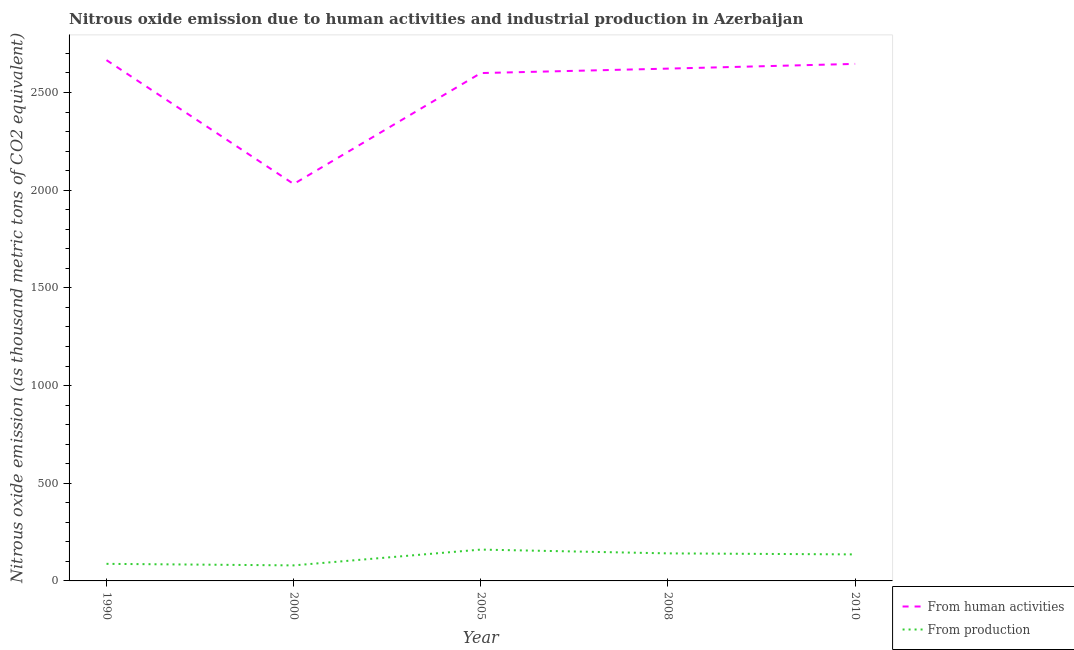Does the line corresponding to amount of emissions generated from industries intersect with the line corresponding to amount of emissions from human activities?
Offer a very short reply. No. What is the amount of emissions from human activities in 2000?
Ensure brevity in your answer.  2031.7. Across all years, what is the maximum amount of emissions from human activities?
Keep it short and to the point. 2665.8. Across all years, what is the minimum amount of emissions from human activities?
Your answer should be very brief. 2031.7. In which year was the amount of emissions from human activities maximum?
Ensure brevity in your answer.  1990. What is the total amount of emissions generated from industries in the graph?
Your response must be concise. 604. What is the difference between the amount of emissions generated from industries in 2000 and that in 2008?
Ensure brevity in your answer.  -61.5. What is the difference between the amount of emissions generated from industries in 2008 and the amount of emissions from human activities in 2005?
Keep it short and to the point. -2458.6. What is the average amount of emissions generated from industries per year?
Your response must be concise. 120.8. In the year 2005, what is the difference between the amount of emissions generated from industries and amount of emissions from human activities?
Ensure brevity in your answer.  -2439.2. What is the ratio of the amount of emissions generated from industries in 1990 to that in 2008?
Offer a terse response. 0.62. Is the difference between the amount of emissions from human activities in 2000 and 2005 greater than the difference between the amount of emissions generated from industries in 2000 and 2005?
Offer a very short reply. No. What is the difference between the highest and the second highest amount of emissions generated from industries?
Your answer should be very brief. 19.4. What is the difference between the highest and the lowest amount of emissions from human activities?
Keep it short and to the point. 634.1. In how many years, is the amount of emissions from human activities greater than the average amount of emissions from human activities taken over all years?
Keep it short and to the point. 4. Is the sum of the amount of emissions generated from industries in 1990 and 2008 greater than the maximum amount of emissions from human activities across all years?
Make the answer very short. No. Does the amount of emissions from human activities monotonically increase over the years?
Offer a very short reply. No. Is the amount of emissions generated from industries strictly greater than the amount of emissions from human activities over the years?
Your response must be concise. No. Is the amount of emissions from human activities strictly less than the amount of emissions generated from industries over the years?
Make the answer very short. No. How many years are there in the graph?
Give a very brief answer. 5. What is the difference between two consecutive major ticks on the Y-axis?
Ensure brevity in your answer.  500. Are the values on the major ticks of Y-axis written in scientific E-notation?
Your answer should be compact. No. How many legend labels are there?
Your response must be concise. 2. How are the legend labels stacked?
Ensure brevity in your answer.  Vertical. What is the title of the graph?
Provide a short and direct response. Nitrous oxide emission due to human activities and industrial production in Azerbaijan. What is the label or title of the Y-axis?
Provide a short and direct response. Nitrous oxide emission (as thousand metric tons of CO2 equivalent). What is the Nitrous oxide emission (as thousand metric tons of CO2 equivalent) in From human activities in 1990?
Your answer should be compact. 2665.8. What is the Nitrous oxide emission (as thousand metric tons of CO2 equivalent) of From production in 1990?
Ensure brevity in your answer.  87.4. What is the Nitrous oxide emission (as thousand metric tons of CO2 equivalent) in From human activities in 2000?
Provide a succinct answer. 2031.7. What is the Nitrous oxide emission (as thousand metric tons of CO2 equivalent) of From production in 2000?
Provide a short and direct response. 79.5. What is the Nitrous oxide emission (as thousand metric tons of CO2 equivalent) of From human activities in 2005?
Ensure brevity in your answer.  2599.6. What is the Nitrous oxide emission (as thousand metric tons of CO2 equivalent) in From production in 2005?
Your response must be concise. 160.4. What is the Nitrous oxide emission (as thousand metric tons of CO2 equivalent) in From human activities in 2008?
Keep it short and to the point. 2622.4. What is the Nitrous oxide emission (as thousand metric tons of CO2 equivalent) in From production in 2008?
Your response must be concise. 141. What is the Nitrous oxide emission (as thousand metric tons of CO2 equivalent) of From human activities in 2010?
Provide a short and direct response. 2646.6. What is the Nitrous oxide emission (as thousand metric tons of CO2 equivalent) of From production in 2010?
Give a very brief answer. 135.7. Across all years, what is the maximum Nitrous oxide emission (as thousand metric tons of CO2 equivalent) in From human activities?
Give a very brief answer. 2665.8. Across all years, what is the maximum Nitrous oxide emission (as thousand metric tons of CO2 equivalent) in From production?
Offer a terse response. 160.4. Across all years, what is the minimum Nitrous oxide emission (as thousand metric tons of CO2 equivalent) in From human activities?
Your answer should be compact. 2031.7. Across all years, what is the minimum Nitrous oxide emission (as thousand metric tons of CO2 equivalent) of From production?
Your response must be concise. 79.5. What is the total Nitrous oxide emission (as thousand metric tons of CO2 equivalent) in From human activities in the graph?
Your answer should be compact. 1.26e+04. What is the total Nitrous oxide emission (as thousand metric tons of CO2 equivalent) in From production in the graph?
Your response must be concise. 604. What is the difference between the Nitrous oxide emission (as thousand metric tons of CO2 equivalent) in From human activities in 1990 and that in 2000?
Keep it short and to the point. 634.1. What is the difference between the Nitrous oxide emission (as thousand metric tons of CO2 equivalent) in From production in 1990 and that in 2000?
Make the answer very short. 7.9. What is the difference between the Nitrous oxide emission (as thousand metric tons of CO2 equivalent) of From human activities in 1990 and that in 2005?
Ensure brevity in your answer.  66.2. What is the difference between the Nitrous oxide emission (as thousand metric tons of CO2 equivalent) in From production in 1990 and that in 2005?
Make the answer very short. -73. What is the difference between the Nitrous oxide emission (as thousand metric tons of CO2 equivalent) of From human activities in 1990 and that in 2008?
Offer a terse response. 43.4. What is the difference between the Nitrous oxide emission (as thousand metric tons of CO2 equivalent) in From production in 1990 and that in 2008?
Provide a short and direct response. -53.6. What is the difference between the Nitrous oxide emission (as thousand metric tons of CO2 equivalent) in From human activities in 1990 and that in 2010?
Provide a short and direct response. 19.2. What is the difference between the Nitrous oxide emission (as thousand metric tons of CO2 equivalent) of From production in 1990 and that in 2010?
Offer a very short reply. -48.3. What is the difference between the Nitrous oxide emission (as thousand metric tons of CO2 equivalent) in From human activities in 2000 and that in 2005?
Offer a terse response. -567.9. What is the difference between the Nitrous oxide emission (as thousand metric tons of CO2 equivalent) in From production in 2000 and that in 2005?
Provide a short and direct response. -80.9. What is the difference between the Nitrous oxide emission (as thousand metric tons of CO2 equivalent) in From human activities in 2000 and that in 2008?
Your answer should be very brief. -590.7. What is the difference between the Nitrous oxide emission (as thousand metric tons of CO2 equivalent) of From production in 2000 and that in 2008?
Provide a short and direct response. -61.5. What is the difference between the Nitrous oxide emission (as thousand metric tons of CO2 equivalent) in From human activities in 2000 and that in 2010?
Your response must be concise. -614.9. What is the difference between the Nitrous oxide emission (as thousand metric tons of CO2 equivalent) of From production in 2000 and that in 2010?
Your response must be concise. -56.2. What is the difference between the Nitrous oxide emission (as thousand metric tons of CO2 equivalent) in From human activities in 2005 and that in 2008?
Ensure brevity in your answer.  -22.8. What is the difference between the Nitrous oxide emission (as thousand metric tons of CO2 equivalent) of From human activities in 2005 and that in 2010?
Provide a succinct answer. -47. What is the difference between the Nitrous oxide emission (as thousand metric tons of CO2 equivalent) of From production in 2005 and that in 2010?
Offer a very short reply. 24.7. What is the difference between the Nitrous oxide emission (as thousand metric tons of CO2 equivalent) of From human activities in 2008 and that in 2010?
Make the answer very short. -24.2. What is the difference between the Nitrous oxide emission (as thousand metric tons of CO2 equivalent) of From production in 2008 and that in 2010?
Make the answer very short. 5.3. What is the difference between the Nitrous oxide emission (as thousand metric tons of CO2 equivalent) in From human activities in 1990 and the Nitrous oxide emission (as thousand metric tons of CO2 equivalent) in From production in 2000?
Your answer should be very brief. 2586.3. What is the difference between the Nitrous oxide emission (as thousand metric tons of CO2 equivalent) in From human activities in 1990 and the Nitrous oxide emission (as thousand metric tons of CO2 equivalent) in From production in 2005?
Give a very brief answer. 2505.4. What is the difference between the Nitrous oxide emission (as thousand metric tons of CO2 equivalent) of From human activities in 1990 and the Nitrous oxide emission (as thousand metric tons of CO2 equivalent) of From production in 2008?
Make the answer very short. 2524.8. What is the difference between the Nitrous oxide emission (as thousand metric tons of CO2 equivalent) in From human activities in 1990 and the Nitrous oxide emission (as thousand metric tons of CO2 equivalent) in From production in 2010?
Offer a very short reply. 2530.1. What is the difference between the Nitrous oxide emission (as thousand metric tons of CO2 equivalent) of From human activities in 2000 and the Nitrous oxide emission (as thousand metric tons of CO2 equivalent) of From production in 2005?
Provide a succinct answer. 1871.3. What is the difference between the Nitrous oxide emission (as thousand metric tons of CO2 equivalent) of From human activities in 2000 and the Nitrous oxide emission (as thousand metric tons of CO2 equivalent) of From production in 2008?
Your response must be concise. 1890.7. What is the difference between the Nitrous oxide emission (as thousand metric tons of CO2 equivalent) of From human activities in 2000 and the Nitrous oxide emission (as thousand metric tons of CO2 equivalent) of From production in 2010?
Offer a very short reply. 1896. What is the difference between the Nitrous oxide emission (as thousand metric tons of CO2 equivalent) of From human activities in 2005 and the Nitrous oxide emission (as thousand metric tons of CO2 equivalent) of From production in 2008?
Provide a short and direct response. 2458.6. What is the difference between the Nitrous oxide emission (as thousand metric tons of CO2 equivalent) of From human activities in 2005 and the Nitrous oxide emission (as thousand metric tons of CO2 equivalent) of From production in 2010?
Keep it short and to the point. 2463.9. What is the difference between the Nitrous oxide emission (as thousand metric tons of CO2 equivalent) in From human activities in 2008 and the Nitrous oxide emission (as thousand metric tons of CO2 equivalent) in From production in 2010?
Provide a succinct answer. 2486.7. What is the average Nitrous oxide emission (as thousand metric tons of CO2 equivalent) in From human activities per year?
Provide a succinct answer. 2513.22. What is the average Nitrous oxide emission (as thousand metric tons of CO2 equivalent) of From production per year?
Provide a succinct answer. 120.8. In the year 1990, what is the difference between the Nitrous oxide emission (as thousand metric tons of CO2 equivalent) in From human activities and Nitrous oxide emission (as thousand metric tons of CO2 equivalent) in From production?
Ensure brevity in your answer.  2578.4. In the year 2000, what is the difference between the Nitrous oxide emission (as thousand metric tons of CO2 equivalent) in From human activities and Nitrous oxide emission (as thousand metric tons of CO2 equivalent) in From production?
Provide a succinct answer. 1952.2. In the year 2005, what is the difference between the Nitrous oxide emission (as thousand metric tons of CO2 equivalent) in From human activities and Nitrous oxide emission (as thousand metric tons of CO2 equivalent) in From production?
Provide a short and direct response. 2439.2. In the year 2008, what is the difference between the Nitrous oxide emission (as thousand metric tons of CO2 equivalent) of From human activities and Nitrous oxide emission (as thousand metric tons of CO2 equivalent) of From production?
Provide a succinct answer. 2481.4. In the year 2010, what is the difference between the Nitrous oxide emission (as thousand metric tons of CO2 equivalent) in From human activities and Nitrous oxide emission (as thousand metric tons of CO2 equivalent) in From production?
Your answer should be very brief. 2510.9. What is the ratio of the Nitrous oxide emission (as thousand metric tons of CO2 equivalent) of From human activities in 1990 to that in 2000?
Keep it short and to the point. 1.31. What is the ratio of the Nitrous oxide emission (as thousand metric tons of CO2 equivalent) of From production in 1990 to that in 2000?
Offer a terse response. 1.1. What is the ratio of the Nitrous oxide emission (as thousand metric tons of CO2 equivalent) in From human activities in 1990 to that in 2005?
Keep it short and to the point. 1.03. What is the ratio of the Nitrous oxide emission (as thousand metric tons of CO2 equivalent) in From production in 1990 to that in 2005?
Make the answer very short. 0.54. What is the ratio of the Nitrous oxide emission (as thousand metric tons of CO2 equivalent) in From human activities in 1990 to that in 2008?
Offer a very short reply. 1.02. What is the ratio of the Nitrous oxide emission (as thousand metric tons of CO2 equivalent) in From production in 1990 to that in 2008?
Offer a terse response. 0.62. What is the ratio of the Nitrous oxide emission (as thousand metric tons of CO2 equivalent) of From human activities in 1990 to that in 2010?
Your answer should be compact. 1.01. What is the ratio of the Nitrous oxide emission (as thousand metric tons of CO2 equivalent) in From production in 1990 to that in 2010?
Provide a short and direct response. 0.64. What is the ratio of the Nitrous oxide emission (as thousand metric tons of CO2 equivalent) of From human activities in 2000 to that in 2005?
Keep it short and to the point. 0.78. What is the ratio of the Nitrous oxide emission (as thousand metric tons of CO2 equivalent) of From production in 2000 to that in 2005?
Your answer should be very brief. 0.5. What is the ratio of the Nitrous oxide emission (as thousand metric tons of CO2 equivalent) of From human activities in 2000 to that in 2008?
Keep it short and to the point. 0.77. What is the ratio of the Nitrous oxide emission (as thousand metric tons of CO2 equivalent) of From production in 2000 to that in 2008?
Offer a very short reply. 0.56. What is the ratio of the Nitrous oxide emission (as thousand metric tons of CO2 equivalent) in From human activities in 2000 to that in 2010?
Give a very brief answer. 0.77. What is the ratio of the Nitrous oxide emission (as thousand metric tons of CO2 equivalent) of From production in 2000 to that in 2010?
Your answer should be very brief. 0.59. What is the ratio of the Nitrous oxide emission (as thousand metric tons of CO2 equivalent) of From human activities in 2005 to that in 2008?
Offer a terse response. 0.99. What is the ratio of the Nitrous oxide emission (as thousand metric tons of CO2 equivalent) in From production in 2005 to that in 2008?
Offer a terse response. 1.14. What is the ratio of the Nitrous oxide emission (as thousand metric tons of CO2 equivalent) in From human activities in 2005 to that in 2010?
Ensure brevity in your answer.  0.98. What is the ratio of the Nitrous oxide emission (as thousand metric tons of CO2 equivalent) of From production in 2005 to that in 2010?
Make the answer very short. 1.18. What is the ratio of the Nitrous oxide emission (as thousand metric tons of CO2 equivalent) of From human activities in 2008 to that in 2010?
Your answer should be compact. 0.99. What is the ratio of the Nitrous oxide emission (as thousand metric tons of CO2 equivalent) of From production in 2008 to that in 2010?
Offer a terse response. 1.04. What is the difference between the highest and the lowest Nitrous oxide emission (as thousand metric tons of CO2 equivalent) in From human activities?
Your response must be concise. 634.1. What is the difference between the highest and the lowest Nitrous oxide emission (as thousand metric tons of CO2 equivalent) in From production?
Your answer should be very brief. 80.9. 